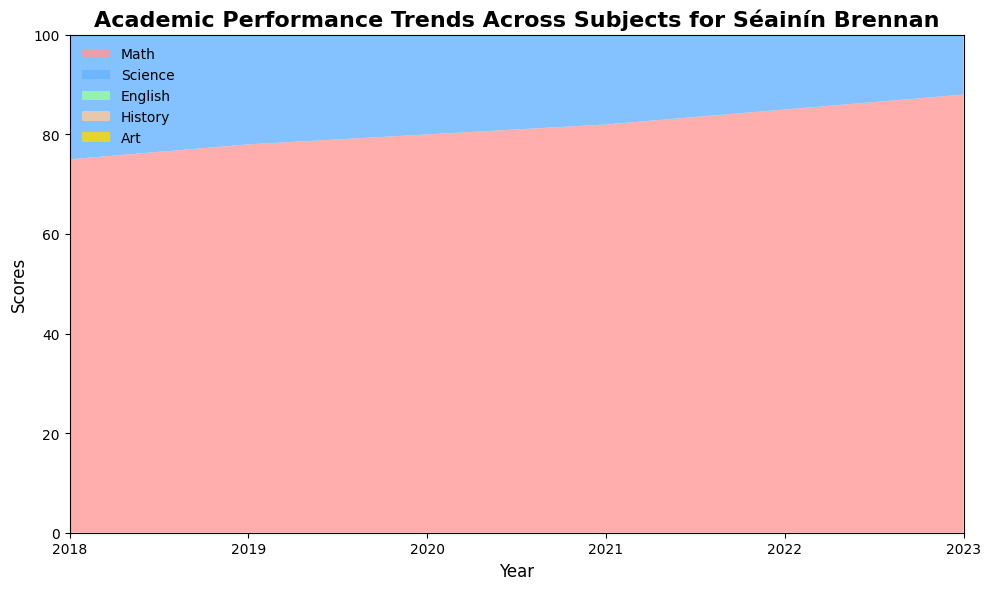What is the highest score achieved in any subject across all years? The highest score across all subjects is seen in the art score in 2023. To determine this, we review the area chart and identify the peak of the stacked areas. Art reaches a score of 94 in 2023.
Answer: 94 How did the scores in Science compare between 2018 and 2023? In 2018, the Science score was 80, and in 2023, the Science score was 91. By comparing these two values, we can see the increase from 80 to 91 across the years.
Answer: Increased by 11 Which subject showed the most improvement from 2018 to 2023? By looking at the area chart, we calculate the difference in scores between 2018 and 2023 for each subject. Math improved by 13 (88-75), Science improved by 11 (91-80), English by 12 (82-70), History by 13 (78-65), and Art by 9 (94-85). Therefore, Math and History show the most improvement.
Answer: Math and History What is the average score of History for the years 2018 to 2023? Adding up the History scores (65 + 68 + 70 + 72 + 75 + 78) gives 428. Dividing this by the 6 years (2018 to 2023), the average score is 428/6 which is 71.33.
Answer: 71.33 Which year saw the highest increase in the Math score compared to the previous year? By looking at the Math scores year by year: 75 (2018), 78 (2019), 80 (2020), 82 (2021), 85 (2022), 88 (2023), we calculate the yearly increases: 3 (2019), 2 (2020), 2 (2021), 3 (2022), 3 (2023). The highest increase compared to the previous year is from 2018 to 2019 (3 points).
Answer: 2019 Which two subjects have consistently shown a rise in scores every year from 2018 to 2023? By examining the graphical trends in the area chart, we note the two subjects that show a steady upward trajectory every year. Math and Science demonstrate consistent score increases each year.
Answer: Math and Science During which year was there the smallest gap between the scores of English and Art? To determine this, we need to look at the difference between English and Art scores each year: 2018 (85-70=15), 2019 (87-72=15), 2020 (88-75=13), 2021 (90-77=13), 2022 (92-80=12), 2023 (94-82=12). The smallest gap occurs in 2022 and 2023, which is 12 points.
Answer: 2022 and 2023 What was the trend in English scores from 2018 to 2023? The English scores over the years are 70 (2018), 72 (2019), 75 (2020), 77 (2021), 80 (2022), 82 (2023). Reviewing these values shows a steady increase every year.
Answer: Increasing By how much did the Art score increase from 2018 to 2021? The Art scores for 2018 and 2021 are 85 and 90, respectively. The difference between these scores is 90 - 85 = 5.
Answer: 5 What is the difference between the highest Math score and the highest History score in the given years? The highest Math score is 88 (2023), and the highest History score is 78 (2023). The difference is 88 - 78 = 10.
Answer: 10 